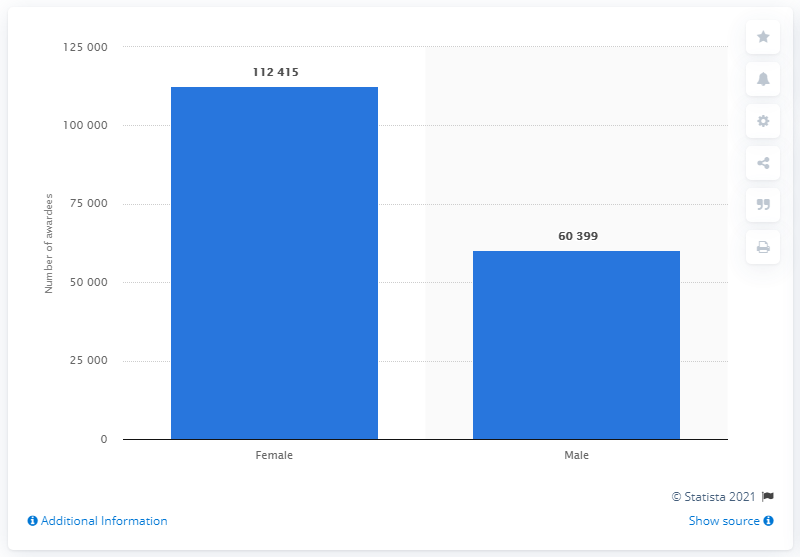Point out several critical features in this image. In 2019, a total of 112,415 female students were awarded their undergraduate degrees in Kerala. 